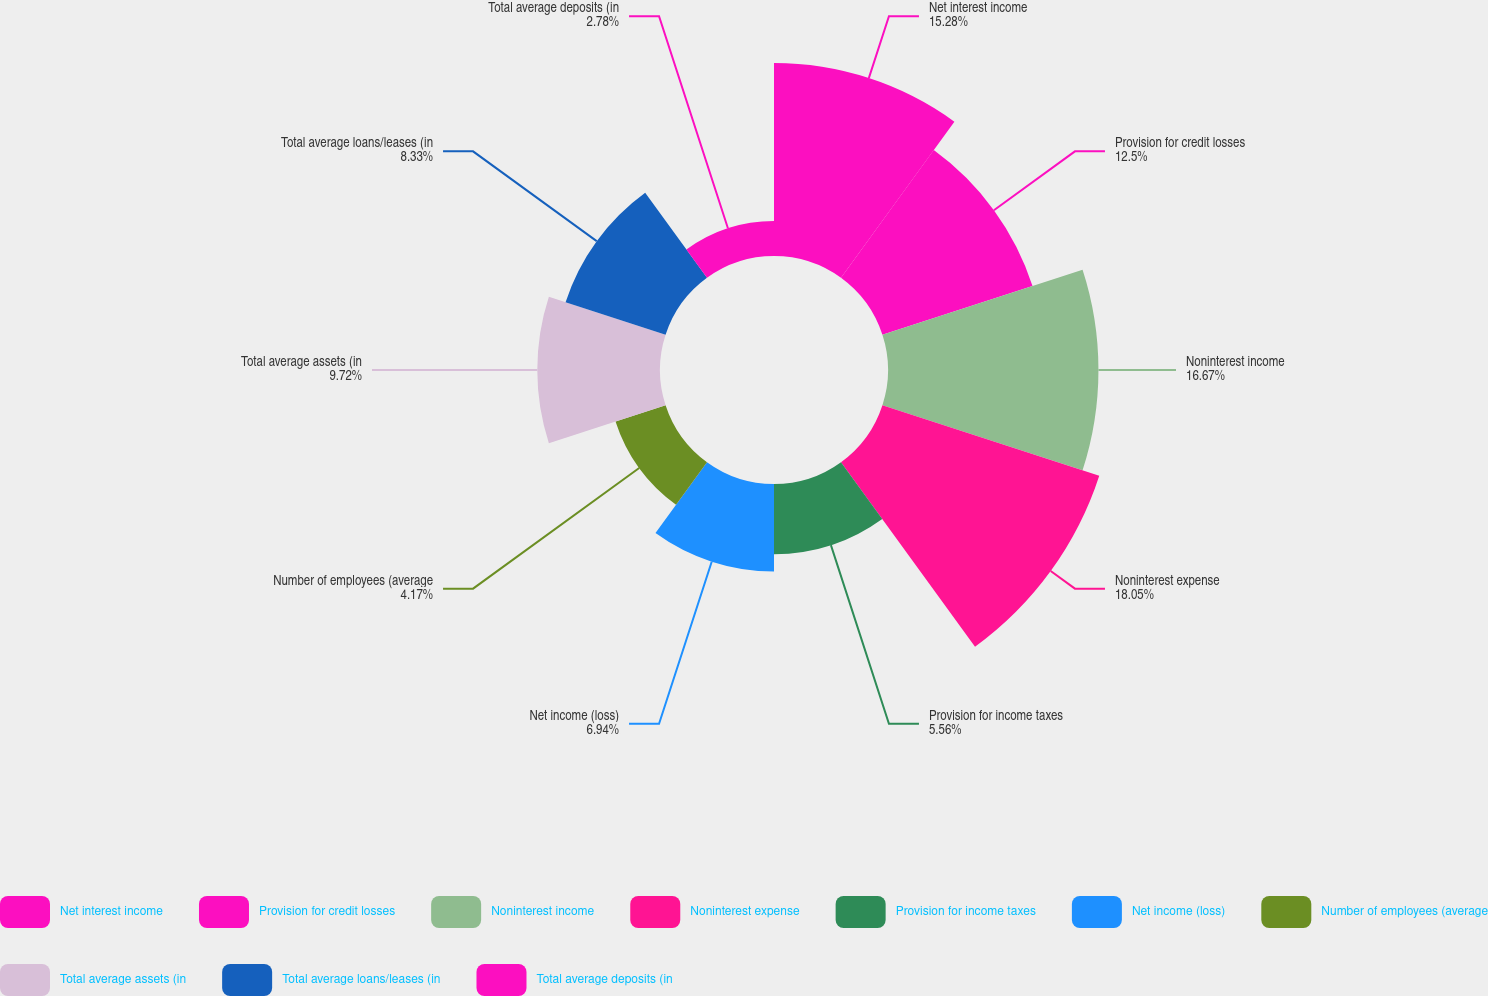<chart> <loc_0><loc_0><loc_500><loc_500><pie_chart><fcel>Net interest income<fcel>Provision for credit losses<fcel>Noninterest income<fcel>Noninterest expense<fcel>Provision for income taxes<fcel>Net income (loss)<fcel>Number of employees (average<fcel>Total average assets (in<fcel>Total average loans/leases (in<fcel>Total average deposits (in<nl><fcel>15.28%<fcel>12.5%<fcel>16.67%<fcel>18.06%<fcel>5.56%<fcel>6.94%<fcel>4.17%<fcel>9.72%<fcel>8.33%<fcel>2.78%<nl></chart> 